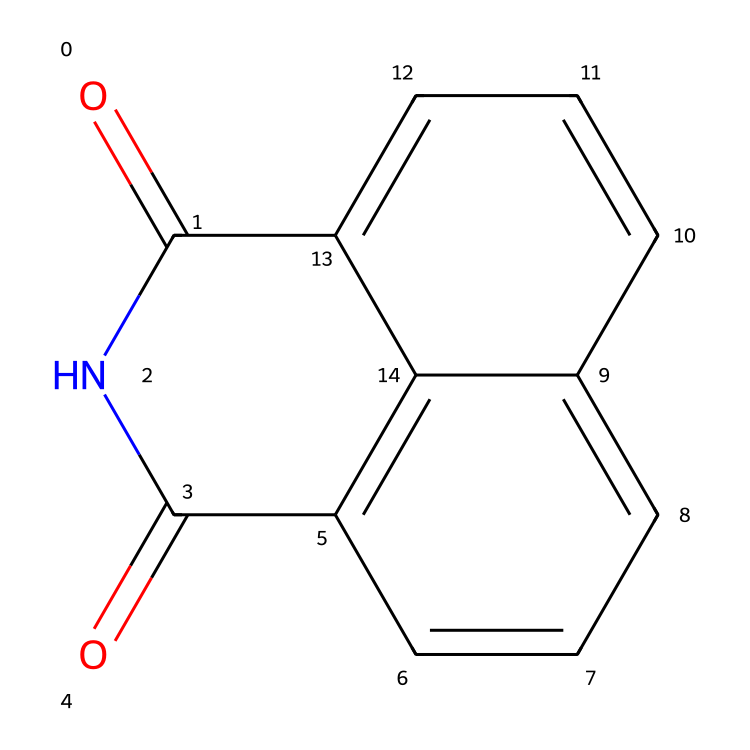What is the main structural feature indicating that this compound is an imide? The presence of the cyclic amide structure is key for identifying it as an imide, particularly the carbonyl (C=O) groups flanking the nitrogen (N) atom.
Answer: cyclic amide How many carbon atoms are present in naphthalimide? By counting the carbon atoms in the structure, we find there are 10 carbon atoms, visible in the aromatic rings and the backbone of the molecule.
Answer: 10 What is the total number of nitrogen atoms in this chemical? There is one nitrogen atom in the molecular structure, as indicated by the single N present within the imide functional group.
Answer: 1 What property allows naphthalimide to be used in optical brighteners? The extensive π-conjugation in the naphthalene-like structure facilitates light absorption and fluorescence, making it effective in optical brightening applications.
Answer: π-conjugation Which functional groups are present in naphthalimide? The functional groups present in this structure are the imide group (characterized by the C=O and N structure) and aromatic rings (the fused phenyl rings).
Answer: imide and aromatic How does the molecular arrangement of naphthalimide contribute to its flame retardant properties? The stable aromatic structure in naphthalimide provides thermal stability, while the imide groups can promote char formation, enhancing flame retardancy.
Answer: thermal stability and char formation 